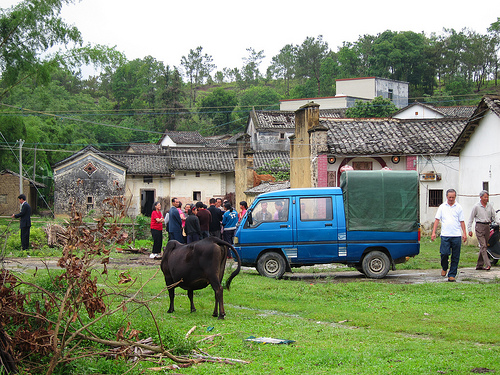<image>
Is there a animal in front of the truck? Yes. The animal is positioned in front of the truck, appearing closer to the camera viewpoint. 